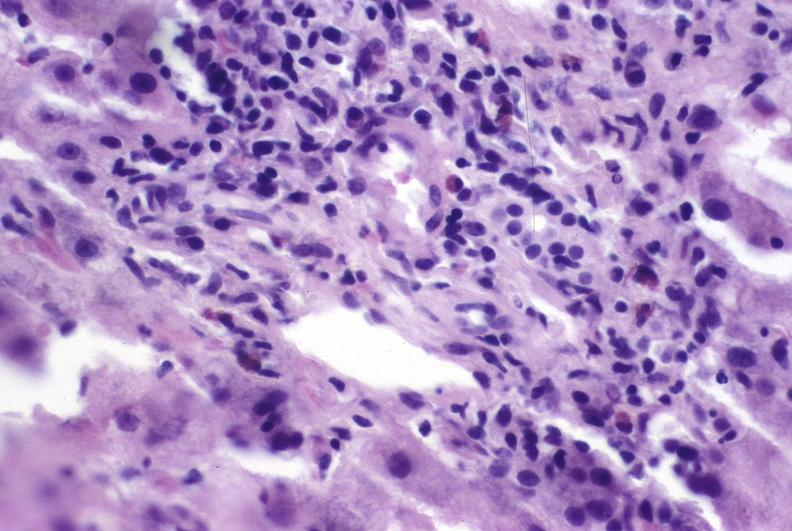what does this image show?
Answer the question using a single word or phrase. Autoimmune hepatitis 